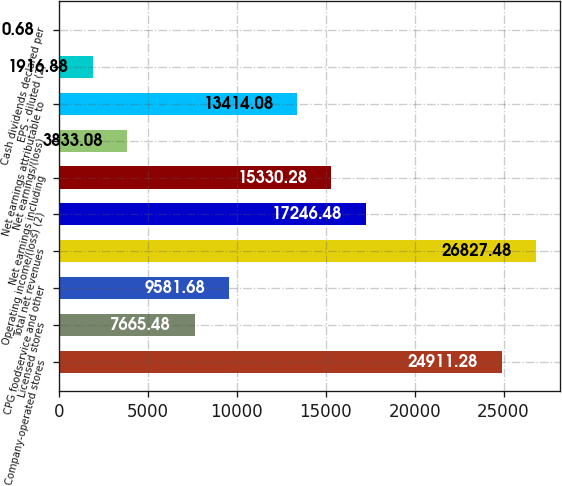Convert chart to OTSL. <chart><loc_0><loc_0><loc_500><loc_500><bar_chart><fcel>Company-operated stores<fcel>Licensed stores<fcel>CPG foodservice and other<fcel>Total net revenues<fcel>Operating income/(loss) (2)<fcel>Net earnings including<fcel>Net earnings/(loss)<fcel>Net earnings attributable to<fcel>EPS - diluted (2)<fcel>Cash dividends declared per<nl><fcel>24911.3<fcel>7665.48<fcel>9581.68<fcel>26827.5<fcel>17246.5<fcel>15330.3<fcel>3833.08<fcel>13414.1<fcel>1916.88<fcel>0.68<nl></chart> 